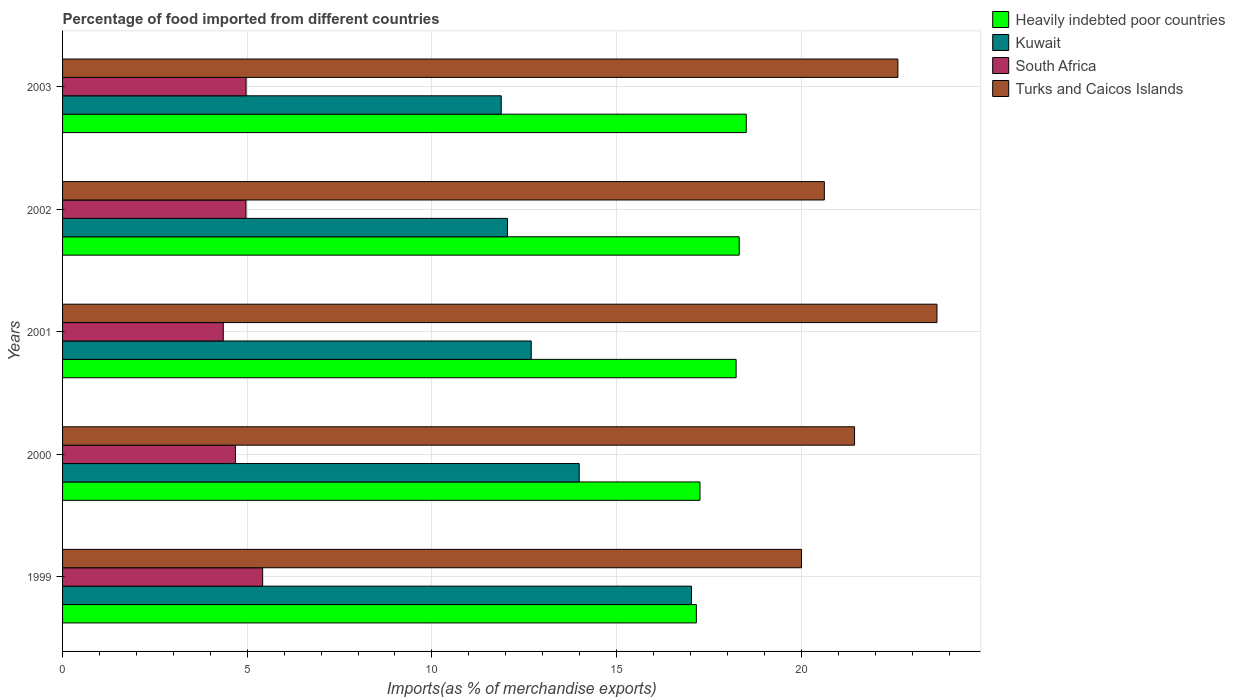How many different coloured bars are there?
Give a very brief answer. 4. Are the number of bars per tick equal to the number of legend labels?
Your answer should be compact. Yes. Are the number of bars on each tick of the Y-axis equal?
Offer a terse response. Yes. How many bars are there on the 5th tick from the bottom?
Offer a very short reply. 4. What is the label of the 5th group of bars from the top?
Offer a very short reply. 1999. In how many cases, is the number of bars for a given year not equal to the number of legend labels?
Give a very brief answer. 0. What is the percentage of imports to different countries in Kuwait in 2001?
Make the answer very short. 12.69. Across all years, what is the maximum percentage of imports to different countries in South Africa?
Give a very brief answer. 5.42. Across all years, what is the minimum percentage of imports to different countries in Heavily indebted poor countries?
Your response must be concise. 17.16. In which year was the percentage of imports to different countries in Heavily indebted poor countries maximum?
Your answer should be very brief. 2003. In which year was the percentage of imports to different countries in Turks and Caicos Islands minimum?
Ensure brevity in your answer.  1999. What is the total percentage of imports to different countries in Kuwait in the graph?
Give a very brief answer. 67.63. What is the difference between the percentage of imports to different countries in Heavily indebted poor countries in 2000 and that in 2002?
Keep it short and to the point. -1.06. What is the difference between the percentage of imports to different countries in Kuwait in 2001 and the percentage of imports to different countries in Turks and Caicos Islands in 2003?
Provide a succinct answer. -9.93. What is the average percentage of imports to different countries in South Africa per year?
Provide a succinct answer. 4.88. In the year 2000, what is the difference between the percentage of imports to different countries in Heavily indebted poor countries and percentage of imports to different countries in Turks and Caicos Islands?
Your answer should be very brief. -4.18. In how many years, is the percentage of imports to different countries in South Africa greater than 6 %?
Your answer should be compact. 0. What is the ratio of the percentage of imports to different countries in Heavily indebted poor countries in 1999 to that in 2001?
Give a very brief answer. 0.94. What is the difference between the highest and the second highest percentage of imports to different countries in Kuwait?
Provide a short and direct response. 3.04. What is the difference between the highest and the lowest percentage of imports to different countries in Heavily indebted poor countries?
Offer a terse response. 1.35. Is the sum of the percentage of imports to different countries in Heavily indebted poor countries in 2001 and 2002 greater than the maximum percentage of imports to different countries in Kuwait across all years?
Your response must be concise. Yes. Is it the case that in every year, the sum of the percentage of imports to different countries in Kuwait and percentage of imports to different countries in Turks and Caicos Islands is greater than the sum of percentage of imports to different countries in Heavily indebted poor countries and percentage of imports to different countries in South Africa?
Make the answer very short. No. What does the 4th bar from the top in 1999 represents?
Give a very brief answer. Heavily indebted poor countries. What does the 2nd bar from the bottom in 2003 represents?
Your response must be concise. Kuwait. How many bars are there?
Keep it short and to the point. 20. What is the difference between two consecutive major ticks on the X-axis?
Give a very brief answer. 5. Are the values on the major ticks of X-axis written in scientific E-notation?
Your answer should be compact. No. What is the title of the graph?
Offer a terse response. Percentage of food imported from different countries. Does "Argentina" appear as one of the legend labels in the graph?
Give a very brief answer. No. What is the label or title of the X-axis?
Make the answer very short. Imports(as % of merchandise exports). What is the label or title of the Y-axis?
Your response must be concise. Years. What is the Imports(as % of merchandise exports) of Heavily indebted poor countries in 1999?
Offer a terse response. 17.16. What is the Imports(as % of merchandise exports) of Kuwait in 1999?
Your response must be concise. 17.03. What is the Imports(as % of merchandise exports) of South Africa in 1999?
Offer a very short reply. 5.42. What is the Imports(as % of merchandise exports) in Turks and Caicos Islands in 1999?
Make the answer very short. 20.01. What is the Imports(as % of merchandise exports) of Heavily indebted poor countries in 2000?
Your response must be concise. 17.26. What is the Imports(as % of merchandise exports) of Kuwait in 2000?
Offer a very short reply. 13.99. What is the Imports(as % of merchandise exports) in South Africa in 2000?
Your answer should be very brief. 4.68. What is the Imports(as % of merchandise exports) of Turks and Caicos Islands in 2000?
Provide a short and direct response. 21.44. What is the Imports(as % of merchandise exports) of Heavily indebted poor countries in 2001?
Your response must be concise. 18.24. What is the Imports(as % of merchandise exports) of Kuwait in 2001?
Make the answer very short. 12.69. What is the Imports(as % of merchandise exports) in South Africa in 2001?
Your response must be concise. 4.35. What is the Imports(as % of merchandise exports) of Turks and Caicos Islands in 2001?
Your answer should be compact. 23.67. What is the Imports(as % of merchandise exports) in Heavily indebted poor countries in 2002?
Make the answer very short. 18.32. What is the Imports(as % of merchandise exports) of Kuwait in 2002?
Your answer should be compact. 12.05. What is the Imports(as % of merchandise exports) in South Africa in 2002?
Make the answer very short. 4.97. What is the Imports(as % of merchandise exports) in Turks and Caicos Islands in 2002?
Keep it short and to the point. 20.62. What is the Imports(as % of merchandise exports) in Heavily indebted poor countries in 2003?
Give a very brief answer. 18.51. What is the Imports(as % of merchandise exports) of Kuwait in 2003?
Provide a succinct answer. 11.88. What is the Imports(as % of merchandise exports) in South Africa in 2003?
Offer a very short reply. 4.97. What is the Imports(as % of merchandise exports) of Turks and Caicos Islands in 2003?
Offer a very short reply. 22.62. Across all years, what is the maximum Imports(as % of merchandise exports) of Heavily indebted poor countries?
Make the answer very short. 18.51. Across all years, what is the maximum Imports(as % of merchandise exports) of Kuwait?
Offer a terse response. 17.03. Across all years, what is the maximum Imports(as % of merchandise exports) of South Africa?
Your answer should be very brief. 5.42. Across all years, what is the maximum Imports(as % of merchandise exports) of Turks and Caicos Islands?
Ensure brevity in your answer.  23.67. Across all years, what is the minimum Imports(as % of merchandise exports) in Heavily indebted poor countries?
Keep it short and to the point. 17.16. Across all years, what is the minimum Imports(as % of merchandise exports) in Kuwait?
Your response must be concise. 11.88. Across all years, what is the minimum Imports(as % of merchandise exports) of South Africa?
Provide a short and direct response. 4.35. Across all years, what is the minimum Imports(as % of merchandise exports) of Turks and Caicos Islands?
Make the answer very short. 20.01. What is the total Imports(as % of merchandise exports) of Heavily indebted poor countries in the graph?
Your answer should be very brief. 89.48. What is the total Imports(as % of merchandise exports) of Kuwait in the graph?
Make the answer very short. 67.63. What is the total Imports(as % of merchandise exports) of South Africa in the graph?
Offer a very short reply. 24.38. What is the total Imports(as % of merchandise exports) in Turks and Caicos Islands in the graph?
Provide a short and direct response. 108.36. What is the difference between the Imports(as % of merchandise exports) in Heavily indebted poor countries in 1999 and that in 2000?
Provide a short and direct response. -0.1. What is the difference between the Imports(as % of merchandise exports) of Kuwait in 1999 and that in 2000?
Keep it short and to the point. 3.04. What is the difference between the Imports(as % of merchandise exports) of South Africa in 1999 and that in 2000?
Your answer should be compact. 0.74. What is the difference between the Imports(as % of merchandise exports) in Turks and Caicos Islands in 1999 and that in 2000?
Provide a succinct answer. -1.44. What is the difference between the Imports(as % of merchandise exports) of Heavily indebted poor countries in 1999 and that in 2001?
Your answer should be very brief. -1.08. What is the difference between the Imports(as % of merchandise exports) in Kuwait in 1999 and that in 2001?
Provide a succinct answer. 4.34. What is the difference between the Imports(as % of merchandise exports) of South Africa in 1999 and that in 2001?
Offer a very short reply. 1.07. What is the difference between the Imports(as % of merchandise exports) of Turks and Caicos Islands in 1999 and that in 2001?
Offer a very short reply. -3.67. What is the difference between the Imports(as % of merchandise exports) of Heavily indebted poor countries in 1999 and that in 2002?
Make the answer very short. -1.16. What is the difference between the Imports(as % of merchandise exports) in Kuwait in 1999 and that in 2002?
Offer a terse response. 4.98. What is the difference between the Imports(as % of merchandise exports) in South Africa in 1999 and that in 2002?
Make the answer very short. 0.45. What is the difference between the Imports(as % of merchandise exports) in Turks and Caicos Islands in 1999 and that in 2002?
Provide a short and direct response. -0.62. What is the difference between the Imports(as % of merchandise exports) in Heavily indebted poor countries in 1999 and that in 2003?
Your answer should be very brief. -1.35. What is the difference between the Imports(as % of merchandise exports) of Kuwait in 1999 and that in 2003?
Your response must be concise. 5.15. What is the difference between the Imports(as % of merchandise exports) of South Africa in 1999 and that in 2003?
Ensure brevity in your answer.  0.45. What is the difference between the Imports(as % of merchandise exports) of Turks and Caicos Islands in 1999 and that in 2003?
Your response must be concise. -2.61. What is the difference between the Imports(as % of merchandise exports) in Heavily indebted poor countries in 2000 and that in 2001?
Offer a terse response. -0.98. What is the difference between the Imports(as % of merchandise exports) in Kuwait in 2000 and that in 2001?
Your answer should be very brief. 1.3. What is the difference between the Imports(as % of merchandise exports) of South Africa in 2000 and that in 2001?
Provide a short and direct response. 0.33. What is the difference between the Imports(as % of merchandise exports) of Turks and Caicos Islands in 2000 and that in 2001?
Keep it short and to the point. -2.23. What is the difference between the Imports(as % of merchandise exports) in Heavily indebted poor countries in 2000 and that in 2002?
Make the answer very short. -1.06. What is the difference between the Imports(as % of merchandise exports) of Kuwait in 2000 and that in 2002?
Your response must be concise. 1.94. What is the difference between the Imports(as % of merchandise exports) of South Africa in 2000 and that in 2002?
Offer a very short reply. -0.29. What is the difference between the Imports(as % of merchandise exports) in Turks and Caicos Islands in 2000 and that in 2002?
Ensure brevity in your answer.  0.82. What is the difference between the Imports(as % of merchandise exports) of Heavily indebted poor countries in 2000 and that in 2003?
Make the answer very short. -1.25. What is the difference between the Imports(as % of merchandise exports) of Kuwait in 2000 and that in 2003?
Make the answer very short. 2.11. What is the difference between the Imports(as % of merchandise exports) in South Africa in 2000 and that in 2003?
Keep it short and to the point. -0.29. What is the difference between the Imports(as % of merchandise exports) in Turks and Caicos Islands in 2000 and that in 2003?
Make the answer very short. -1.17. What is the difference between the Imports(as % of merchandise exports) of Heavily indebted poor countries in 2001 and that in 2002?
Provide a succinct answer. -0.08. What is the difference between the Imports(as % of merchandise exports) in Kuwait in 2001 and that in 2002?
Your answer should be very brief. 0.64. What is the difference between the Imports(as % of merchandise exports) of South Africa in 2001 and that in 2002?
Give a very brief answer. -0.61. What is the difference between the Imports(as % of merchandise exports) in Turks and Caicos Islands in 2001 and that in 2002?
Provide a short and direct response. 3.05. What is the difference between the Imports(as % of merchandise exports) in Heavily indebted poor countries in 2001 and that in 2003?
Offer a very short reply. -0.28. What is the difference between the Imports(as % of merchandise exports) of Kuwait in 2001 and that in 2003?
Ensure brevity in your answer.  0.81. What is the difference between the Imports(as % of merchandise exports) of South Africa in 2001 and that in 2003?
Your answer should be compact. -0.62. What is the difference between the Imports(as % of merchandise exports) in Turks and Caicos Islands in 2001 and that in 2003?
Give a very brief answer. 1.06. What is the difference between the Imports(as % of merchandise exports) of Heavily indebted poor countries in 2002 and that in 2003?
Your answer should be compact. -0.19. What is the difference between the Imports(as % of merchandise exports) of Kuwait in 2002 and that in 2003?
Keep it short and to the point. 0.17. What is the difference between the Imports(as % of merchandise exports) in South Africa in 2002 and that in 2003?
Provide a short and direct response. -0. What is the difference between the Imports(as % of merchandise exports) in Turks and Caicos Islands in 2002 and that in 2003?
Your answer should be compact. -1.99. What is the difference between the Imports(as % of merchandise exports) of Heavily indebted poor countries in 1999 and the Imports(as % of merchandise exports) of Kuwait in 2000?
Make the answer very short. 3.17. What is the difference between the Imports(as % of merchandise exports) of Heavily indebted poor countries in 1999 and the Imports(as % of merchandise exports) of South Africa in 2000?
Provide a short and direct response. 12.48. What is the difference between the Imports(as % of merchandise exports) in Heavily indebted poor countries in 1999 and the Imports(as % of merchandise exports) in Turks and Caicos Islands in 2000?
Provide a succinct answer. -4.28. What is the difference between the Imports(as % of merchandise exports) in Kuwait in 1999 and the Imports(as % of merchandise exports) in South Africa in 2000?
Provide a short and direct response. 12.35. What is the difference between the Imports(as % of merchandise exports) of Kuwait in 1999 and the Imports(as % of merchandise exports) of Turks and Caicos Islands in 2000?
Offer a very short reply. -4.41. What is the difference between the Imports(as % of merchandise exports) in South Africa in 1999 and the Imports(as % of merchandise exports) in Turks and Caicos Islands in 2000?
Provide a short and direct response. -16.02. What is the difference between the Imports(as % of merchandise exports) of Heavily indebted poor countries in 1999 and the Imports(as % of merchandise exports) of Kuwait in 2001?
Offer a terse response. 4.47. What is the difference between the Imports(as % of merchandise exports) in Heavily indebted poor countries in 1999 and the Imports(as % of merchandise exports) in South Africa in 2001?
Your answer should be compact. 12.81. What is the difference between the Imports(as % of merchandise exports) in Heavily indebted poor countries in 1999 and the Imports(as % of merchandise exports) in Turks and Caicos Islands in 2001?
Make the answer very short. -6.51. What is the difference between the Imports(as % of merchandise exports) in Kuwait in 1999 and the Imports(as % of merchandise exports) in South Africa in 2001?
Your response must be concise. 12.68. What is the difference between the Imports(as % of merchandise exports) of Kuwait in 1999 and the Imports(as % of merchandise exports) of Turks and Caicos Islands in 2001?
Offer a terse response. -6.65. What is the difference between the Imports(as % of merchandise exports) of South Africa in 1999 and the Imports(as % of merchandise exports) of Turks and Caicos Islands in 2001?
Provide a succinct answer. -18.26. What is the difference between the Imports(as % of merchandise exports) of Heavily indebted poor countries in 1999 and the Imports(as % of merchandise exports) of Kuwait in 2002?
Keep it short and to the point. 5.11. What is the difference between the Imports(as % of merchandise exports) in Heavily indebted poor countries in 1999 and the Imports(as % of merchandise exports) in South Africa in 2002?
Ensure brevity in your answer.  12.19. What is the difference between the Imports(as % of merchandise exports) in Heavily indebted poor countries in 1999 and the Imports(as % of merchandise exports) in Turks and Caicos Islands in 2002?
Your answer should be compact. -3.47. What is the difference between the Imports(as % of merchandise exports) of Kuwait in 1999 and the Imports(as % of merchandise exports) of South Africa in 2002?
Provide a short and direct response. 12.06. What is the difference between the Imports(as % of merchandise exports) of Kuwait in 1999 and the Imports(as % of merchandise exports) of Turks and Caicos Islands in 2002?
Your answer should be compact. -3.6. What is the difference between the Imports(as % of merchandise exports) of South Africa in 1999 and the Imports(as % of merchandise exports) of Turks and Caicos Islands in 2002?
Give a very brief answer. -15.21. What is the difference between the Imports(as % of merchandise exports) in Heavily indebted poor countries in 1999 and the Imports(as % of merchandise exports) in Kuwait in 2003?
Your answer should be compact. 5.28. What is the difference between the Imports(as % of merchandise exports) of Heavily indebted poor countries in 1999 and the Imports(as % of merchandise exports) of South Africa in 2003?
Provide a succinct answer. 12.19. What is the difference between the Imports(as % of merchandise exports) in Heavily indebted poor countries in 1999 and the Imports(as % of merchandise exports) in Turks and Caicos Islands in 2003?
Offer a very short reply. -5.46. What is the difference between the Imports(as % of merchandise exports) of Kuwait in 1999 and the Imports(as % of merchandise exports) of South Africa in 2003?
Keep it short and to the point. 12.06. What is the difference between the Imports(as % of merchandise exports) in Kuwait in 1999 and the Imports(as % of merchandise exports) in Turks and Caicos Islands in 2003?
Keep it short and to the point. -5.59. What is the difference between the Imports(as % of merchandise exports) of South Africa in 1999 and the Imports(as % of merchandise exports) of Turks and Caicos Islands in 2003?
Offer a terse response. -17.2. What is the difference between the Imports(as % of merchandise exports) in Heavily indebted poor countries in 2000 and the Imports(as % of merchandise exports) in Kuwait in 2001?
Your answer should be very brief. 4.57. What is the difference between the Imports(as % of merchandise exports) of Heavily indebted poor countries in 2000 and the Imports(as % of merchandise exports) of South Africa in 2001?
Offer a very short reply. 12.91. What is the difference between the Imports(as % of merchandise exports) of Heavily indebted poor countries in 2000 and the Imports(as % of merchandise exports) of Turks and Caicos Islands in 2001?
Provide a succinct answer. -6.42. What is the difference between the Imports(as % of merchandise exports) in Kuwait in 2000 and the Imports(as % of merchandise exports) in South Africa in 2001?
Your answer should be compact. 9.64. What is the difference between the Imports(as % of merchandise exports) in Kuwait in 2000 and the Imports(as % of merchandise exports) in Turks and Caicos Islands in 2001?
Your answer should be very brief. -9.69. What is the difference between the Imports(as % of merchandise exports) of South Africa in 2000 and the Imports(as % of merchandise exports) of Turks and Caicos Islands in 2001?
Offer a terse response. -18.99. What is the difference between the Imports(as % of merchandise exports) in Heavily indebted poor countries in 2000 and the Imports(as % of merchandise exports) in Kuwait in 2002?
Offer a very short reply. 5.21. What is the difference between the Imports(as % of merchandise exports) in Heavily indebted poor countries in 2000 and the Imports(as % of merchandise exports) in South Africa in 2002?
Provide a succinct answer. 12.29. What is the difference between the Imports(as % of merchandise exports) of Heavily indebted poor countries in 2000 and the Imports(as % of merchandise exports) of Turks and Caicos Islands in 2002?
Provide a short and direct response. -3.37. What is the difference between the Imports(as % of merchandise exports) of Kuwait in 2000 and the Imports(as % of merchandise exports) of South Africa in 2002?
Provide a short and direct response. 9.02. What is the difference between the Imports(as % of merchandise exports) in Kuwait in 2000 and the Imports(as % of merchandise exports) in Turks and Caicos Islands in 2002?
Your response must be concise. -6.64. What is the difference between the Imports(as % of merchandise exports) of South Africa in 2000 and the Imports(as % of merchandise exports) of Turks and Caicos Islands in 2002?
Offer a terse response. -15.94. What is the difference between the Imports(as % of merchandise exports) of Heavily indebted poor countries in 2000 and the Imports(as % of merchandise exports) of Kuwait in 2003?
Provide a succinct answer. 5.38. What is the difference between the Imports(as % of merchandise exports) in Heavily indebted poor countries in 2000 and the Imports(as % of merchandise exports) in South Africa in 2003?
Your answer should be compact. 12.29. What is the difference between the Imports(as % of merchandise exports) in Heavily indebted poor countries in 2000 and the Imports(as % of merchandise exports) in Turks and Caicos Islands in 2003?
Provide a short and direct response. -5.36. What is the difference between the Imports(as % of merchandise exports) in Kuwait in 2000 and the Imports(as % of merchandise exports) in South Africa in 2003?
Provide a short and direct response. 9.02. What is the difference between the Imports(as % of merchandise exports) of Kuwait in 2000 and the Imports(as % of merchandise exports) of Turks and Caicos Islands in 2003?
Provide a short and direct response. -8.63. What is the difference between the Imports(as % of merchandise exports) in South Africa in 2000 and the Imports(as % of merchandise exports) in Turks and Caicos Islands in 2003?
Your answer should be very brief. -17.94. What is the difference between the Imports(as % of merchandise exports) in Heavily indebted poor countries in 2001 and the Imports(as % of merchandise exports) in Kuwait in 2002?
Your response must be concise. 6.19. What is the difference between the Imports(as % of merchandise exports) of Heavily indebted poor countries in 2001 and the Imports(as % of merchandise exports) of South Africa in 2002?
Offer a terse response. 13.27. What is the difference between the Imports(as % of merchandise exports) in Heavily indebted poor countries in 2001 and the Imports(as % of merchandise exports) in Turks and Caicos Islands in 2002?
Offer a terse response. -2.39. What is the difference between the Imports(as % of merchandise exports) of Kuwait in 2001 and the Imports(as % of merchandise exports) of South Africa in 2002?
Offer a very short reply. 7.72. What is the difference between the Imports(as % of merchandise exports) in Kuwait in 2001 and the Imports(as % of merchandise exports) in Turks and Caicos Islands in 2002?
Make the answer very short. -7.94. What is the difference between the Imports(as % of merchandise exports) in South Africa in 2001 and the Imports(as % of merchandise exports) in Turks and Caicos Islands in 2002?
Ensure brevity in your answer.  -16.27. What is the difference between the Imports(as % of merchandise exports) in Heavily indebted poor countries in 2001 and the Imports(as % of merchandise exports) in Kuwait in 2003?
Give a very brief answer. 6.36. What is the difference between the Imports(as % of merchandise exports) in Heavily indebted poor countries in 2001 and the Imports(as % of merchandise exports) in South Africa in 2003?
Your response must be concise. 13.27. What is the difference between the Imports(as % of merchandise exports) in Heavily indebted poor countries in 2001 and the Imports(as % of merchandise exports) in Turks and Caicos Islands in 2003?
Your answer should be very brief. -4.38. What is the difference between the Imports(as % of merchandise exports) in Kuwait in 2001 and the Imports(as % of merchandise exports) in South Africa in 2003?
Make the answer very short. 7.72. What is the difference between the Imports(as % of merchandise exports) of Kuwait in 2001 and the Imports(as % of merchandise exports) of Turks and Caicos Islands in 2003?
Keep it short and to the point. -9.93. What is the difference between the Imports(as % of merchandise exports) of South Africa in 2001 and the Imports(as % of merchandise exports) of Turks and Caicos Islands in 2003?
Ensure brevity in your answer.  -18.26. What is the difference between the Imports(as % of merchandise exports) of Heavily indebted poor countries in 2002 and the Imports(as % of merchandise exports) of Kuwait in 2003?
Ensure brevity in your answer.  6.44. What is the difference between the Imports(as % of merchandise exports) in Heavily indebted poor countries in 2002 and the Imports(as % of merchandise exports) in South Africa in 2003?
Offer a terse response. 13.35. What is the difference between the Imports(as % of merchandise exports) in Heavily indebted poor countries in 2002 and the Imports(as % of merchandise exports) in Turks and Caicos Islands in 2003?
Offer a terse response. -4.3. What is the difference between the Imports(as % of merchandise exports) in Kuwait in 2002 and the Imports(as % of merchandise exports) in South Africa in 2003?
Offer a very short reply. 7.08. What is the difference between the Imports(as % of merchandise exports) in Kuwait in 2002 and the Imports(as % of merchandise exports) in Turks and Caicos Islands in 2003?
Keep it short and to the point. -10.57. What is the difference between the Imports(as % of merchandise exports) of South Africa in 2002 and the Imports(as % of merchandise exports) of Turks and Caicos Islands in 2003?
Give a very brief answer. -17.65. What is the average Imports(as % of merchandise exports) of Heavily indebted poor countries per year?
Your answer should be compact. 17.9. What is the average Imports(as % of merchandise exports) in Kuwait per year?
Your answer should be very brief. 13.53. What is the average Imports(as % of merchandise exports) of South Africa per year?
Your answer should be very brief. 4.88. What is the average Imports(as % of merchandise exports) of Turks and Caicos Islands per year?
Your answer should be compact. 21.67. In the year 1999, what is the difference between the Imports(as % of merchandise exports) in Heavily indebted poor countries and Imports(as % of merchandise exports) in Kuwait?
Offer a terse response. 0.13. In the year 1999, what is the difference between the Imports(as % of merchandise exports) of Heavily indebted poor countries and Imports(as % of merchandise exports) of South Africa?
Your answer should be very brief. 11.74. In the year 1999, what is the difference between the Imports(as % of merchandise exports) in Heavily indebted poor countries and Imports(as % of merchandise exports) in Turks and Caicos Islands?
Give a very brief answer. -2.85. In the year 1999, what is the difference between the Imports(as % of merchandise exports) in Kuwait and Imports(as % of merchandise exports) in South Africa?
Offer a terse response. 11.61. In the year 1999, what is the difference between the Imports(as % of merchandise exports) of Kuwait and Imports(as % of merchandise exports) of Turks and Caicos Islands?
Offer a very short reply. -2.98. In the year 1999, what is the difference between the Imports(as % of merchandise exports) in South Africa and Imports(as % of merchandise exports) in Turks and Caicos Islands?
Provide a succinct answer. -14.59. In the year 2000, what is the difference between the Imports(as % of merchandise exports) of Heavily indebted poor countries and Imports(as % of merchandise exports) of Kuwait?
Your answer should be very brief. 3.27. In the year 2000, what is the difference between the Imports(as % of merchandise exports) of Heavily indebted poor countries and Imports(as % of merchandise exports) of South Africa?
Your answer should be compact. 12.58. In the year 2000, what is the difference between the Imports(as % of merchandise exports) in Heavily indebted poor countries and Imports(as % of merchandise exports) in Turks and Caicos Islands?
Provide a short and direct response. -4.18. In the year 2000, what is the difference between the Imports(as % of merchandise exports) in Kuwait and Imports(as % of merchandise exports) in South Africa?
Offer a terse response. 9.31. In the year 2000, what is the difference between the Imports(as % of merchandise exports) in Kuwait and Imports(as % of merchandise exports) in Turks and Caicos Islands?
Give a very brief answer. -7.45. In the year 2000, what is the difference between the Imports(as % of merchandise exports) of South Africa and Imports(as % of merchandise exports) of Turks and Caicos Islands?
Make the answer very short. -16.76. In the year 2001, what is the difference between the Imports(as % of merchandise exports) in Heavily indebted poor countries and Imports(as % of merchandise exports) in Kuwait?
Provide a succinct answer. 5.55. In the year 2001, what is the difference between the Imports(as % of merchandise exports) in Heavily indebted poor countries and Imports(as % of merchandise exports) in South Africa?
Keep it short and to the point. 13.88. In the year 2001, what is the difference between the Imports(as % of merchandise exports) in Heavily indebted poor countries and Imports(as % of merchandise exports) in Turks and Caicos Islands?
Your response must be concise. -5.44. In the year 2001, what is the difference between the Imports(as % of merchandise exports) of Kuwait and Imports(as % of merchandise exports) of South Africa?
Give a very brief answer. 8.34. In the year 2001, what is the difference between the Imports(as % of merchandise exports) of Kuwait and Imports(as % of merchandise exports) of Turks and Caicos Islands?
Ensure brevity in your answer.  -10.98. In the year 2001, what is the difference between the Imports(as % of merchandise exports) in South Africa and Imports(as % of merchandise exports) in Turks and Caicos Islands?
Provide a succinct answer. -19.32. In the year 2002, what is the difference between the Imports(as % of merchandise exports) in Heavily indebted poor countries and Imports(as % of merchandise exports) in Kuwait?
Keep it short and to the point. 6.27. In the year 2002, what is the difference between the Imports(as % of merchandise exports) of Heavily indebted poor countries and Imports(as % of merchandise exports) of South Africa?
Your response must be concise. 13.35. In the year 2002, what is the difference between the Imports(as % of merchandise exports) of Heavily indebted poor countries and Imports(as % of merchandise exports) of Turks and Caicos Islands?
Keep it short and to the point. -2.31. In the year 2002, what is the difference between the Imports(as % of merchandise exports) of Kuwait and Imports(as % of merchandise exports) of South Africa?
Provide a succinct answer. 7.08. In the year 2002, what is the difference between the Imports(as % of merchandise exports) of Kuwait and Imports(as % of merchandise exports) of Turks and Caicos Islands?
Make the answer very short. -8.58. In the year 2002, what is the difference between the Imports(as % of merchandise exports) in South Africa and Imports(as % of merchandise exports) in Turks and Caicos Islands?
Provide a short and direct response. -15.66. In the year 2003, what is the difference between the Imports(as % of merchandise exports) in Heavily indebted poor countries and Imports(as % of merchandise exports) in Kuwait?
Give a very brief answer. 6.63. In the year 2003, what is the difference between the Imports(as % of merchandise exports) in Heavily indebted poor countries and Imports(as % of merchandise exports) in South Africa?
Your response must be concise. 13.54. In the year 2003, what is the difference between the Imports(as % of merchandise exports) of Heavily indebted poor countries and Imports(as % of merchandise exports) of Turks and Caicos Islands?
Offer a very short reply. -4.1. In the year 2003, what is the difference between the Imports(as % of merchandise exports) of Kuwait and Imports(as % of merchandise exports) of South Africa?
Give a very brief answer. 6.91. In the year 2003, what is the difference between the Imports(as % of merchandise exports) in Kuwait and Imports(as % of merchandise exports) in Turks and Caicos Islands?
Ensure brevity in your answer.  -10.74. In the year 2003, what is the difference between the Imports(as % of merchandise exports) in South Africa and Imports(as % of merchandise exports) in Turks and Caicos Islands?
Offer a very short reply. -17.65. What is the ratio of the Imports(as % of merchandise exports) of Heavily indebted poor countries in 1999 to that in 2000?
Offer a terse response. 0.99. What is the ratio of the Imports(as % of merchandise exports) in Kuwait in 1999 to that in 2000?
Offer a terse response. 1.22. What is the ratio of the Imports(as % of merchandise exports) of South Africa in 1999 to that in 2000?
Make the answer very short. 1.16. What is the ratio of the Imports(as % of merchandise exports) of Turks and Caicos Islands in 1999 to that in 2000?
Ensure brevity in your answer.  0.93. What is the ratio of the Imports(as % of merchandise exports) of Heavily indebted poor countries in 1999 to that in 2001?
Offer a very short reply. 0.94. What is the ratio of the Imports(as % of merchandise exports) of Kuwait in 1999 to that in 2001?
Your answer should be very brief. 1.34. What is the ratio of the Imports(as % of merchandise exports) of South Africa in 1999 to that in 2001?
Offer a very short reply. 1.25. What is the ratio of the Imports(as % of merchandise exports) in Turks and Caicos Islands in 1999 to that in 2001?
Your response must be concise. 0.85. What is the ratio of the Imports(as % of merchandise exports) in Heavily indebted poor countries in 1999 to that in 2002?
Provide a succinct answer. 0.94. What is the ratio of the Imports(as % of merchandise exports) in Kuwait in 1999 to that in 2002?
Provide a short and direct response. 1.41. What is the ratio of the Imports(as % of merchandise exports) of South Africa in 1999 to that in 2002?
Your response must be concise. 1.09. What is the ratio of the Imports(as % of merchandise exports) in Turks and Caicos Islands in 1999 to that in 2002?
Your answer should be very brief. 0.97. What is the ratio of the Imports(as % of merchandise exports) of Heavily indebted poor countries in 1999 to that in 2003?
Your answer should be compact. 0.93. What is the ratio of the Imports(as % of merchandise exports) in Kuwait in 1999 to that in 2003?
Offer a terse response. 1.43. What is the ratio of the Imports(as % of merchandise exports) of South Africa in 1999 to that in 2003?
Provide a succinct answer. 1.09. What is the ratio of the Imports(as % of merchandise exports) in Turks and Caicos Islands in 1999 to that in 2003?
Offer a very short reply. 0.88. What is the ratio of the Imports(as % of merchandise exports) in Heavily indebted poor countries in 2000 to that in 2001?
Your response must be concise. 0.95. What is the ratio of the Imports(as % of merchandise exports) of Kuwait in 2000 to that in 2001?
Your answer should be compact. 1.1. What is the ratio of the Imports(as % of merchandise exports) in South Africa in 2000 to that in 2001?
Your answer should be compact. 1.08. What is the ratio of the Imports(as % of merchandise exports) in Turks and Caicos Islands in 2000 to that in 2001?
Offer a terse response. 0.91. What is the ratio of the Imports(as % of merchandise exports) of Heavily indebted poor countries in 2000 to that in 2002?
Provide a succinct answer. 0.94. What is the ratio of the Imports(as % of merchandise exports) in Kuwait in 2000 to that in 2002?
Your answer should be very brief. 1.16. What is the ratio of the Imports(as % of merchandise exports) of South Africa in 2000 to that in 2002?
Offer a very short reply. 0.94. What is the ratio of the Imports(as % of merchandise exports) of Turks and Caicos Islands in 2000 to that in 2002?
Give a very brief answer. 1.04. What is the ratio of the Imports(as % of merchandise exports) in Heavily indebted poor countries in 2000 to that in 2003?
Ensure brevity in your answer.  0.93. What is the ratio of the Imports(as % of merchandise exports) of Kuwait in 2000 to that in 2003?
Your answer should be compact. 1.18. What is the ratio of the Imports(as % of merchandise exports) in South Africa in 2000 to that in 2003?
Offer a terse response. 0.94. What is the ratio of the Imports(as % of merchandise exports) in Turks and Caicos Islands in 2000 to that in 2003?
Keep it short and to the point. 0.95. What is the ratio of the Imports(as % of merchandise exports) of Heavily indebted poor countries in 2001 to that in 2002?
Offer a terse response. 1. What is the ratio of the Imports(as % of merchandise exports) in Kuwait in 2001 to that in 2002?
Keep it short and to the point. 1.05. What is the ratio of the Imports(as % of merchandise exports) in South Africa in 2001 to that in 2002?
Provide a succinct answer. 0.88. What is the ratio of the Imports(as % of merchandise exports) in Turks and Caicos Islands in 2001 to that in 2002?
Your response must be concise. 1.15. What is the ratio of the Imports(as % of merchandise exports) in Heavily indebted poor countries in 2001 to that in 2003?
Your answer should be very brief. 0.99. What is the ratio of the Imports(as % of merchandise exports) of Kuwait in 2001 to that in 2003?
Provide a succinct answer. 1.07. What is the ratio of the Imports(as % of merchandise exports) in South Africa in 2001 to that in 2003?
Ensure brevity in your answer.  0.88. What is the ratio of the Imports(as % of merchandise exports) of Turks and Caicos Islands in 2001 to that in 2003?
Ensure brevity in your answer.  1.05. What is the ratio of the Imports(as % of merchandise exports) in Kuwait in 2002 to that in 2003?
Provide a short and direct response. 1.01. What is the ratio of the Imports(as % of merchandise exports) of South Africa in 2002 to that in 2003?
Your response must be concise. 1. What is the ratio of the Imports(as % of merchandise exports) in Turks and Caicos Islands in 2002 to that in 2003?
Keep it short and to the point. 0.91. What is the difference between the highest and the second highest Imports(as % of merchandise exports) in Heavily indebted poor countries?
Give a very brief answer. 0.19. What is the difference between the highest and the second highest Imports(as % of merchandise exports) in Kuwait?
Offer a terse response. 3.04. What is the difference between the highest and the second highest Imports(as % of merchandise exports) in South Africa?
Your answer should be very brief. 0.45. What is the difference between the highest and the second highest Imports(as % of merchandise exports) in Turks and Caicos Islands?
Keep it short and to the point. 1.06. What is the difference between the highest and the lowest Imports(as % of merchandise exports) in Heavily indebted poor countries?
Keep it short and to the point. 1.35. What is the difference between the highest and the lowest Imports(as % of merchandise exports) in Kuwait?
Offer a terse response. 5.15. What is the difference between the highest and the lowest Imports(as % of merchandise exports) of South Africa?
Keep it short and to the point. 1.07. What is the difference between the highest and the lowest Imports(as % of merchandise exports) of Turks and Caicos Islands?
Keep it short and to the point. 3.67. 